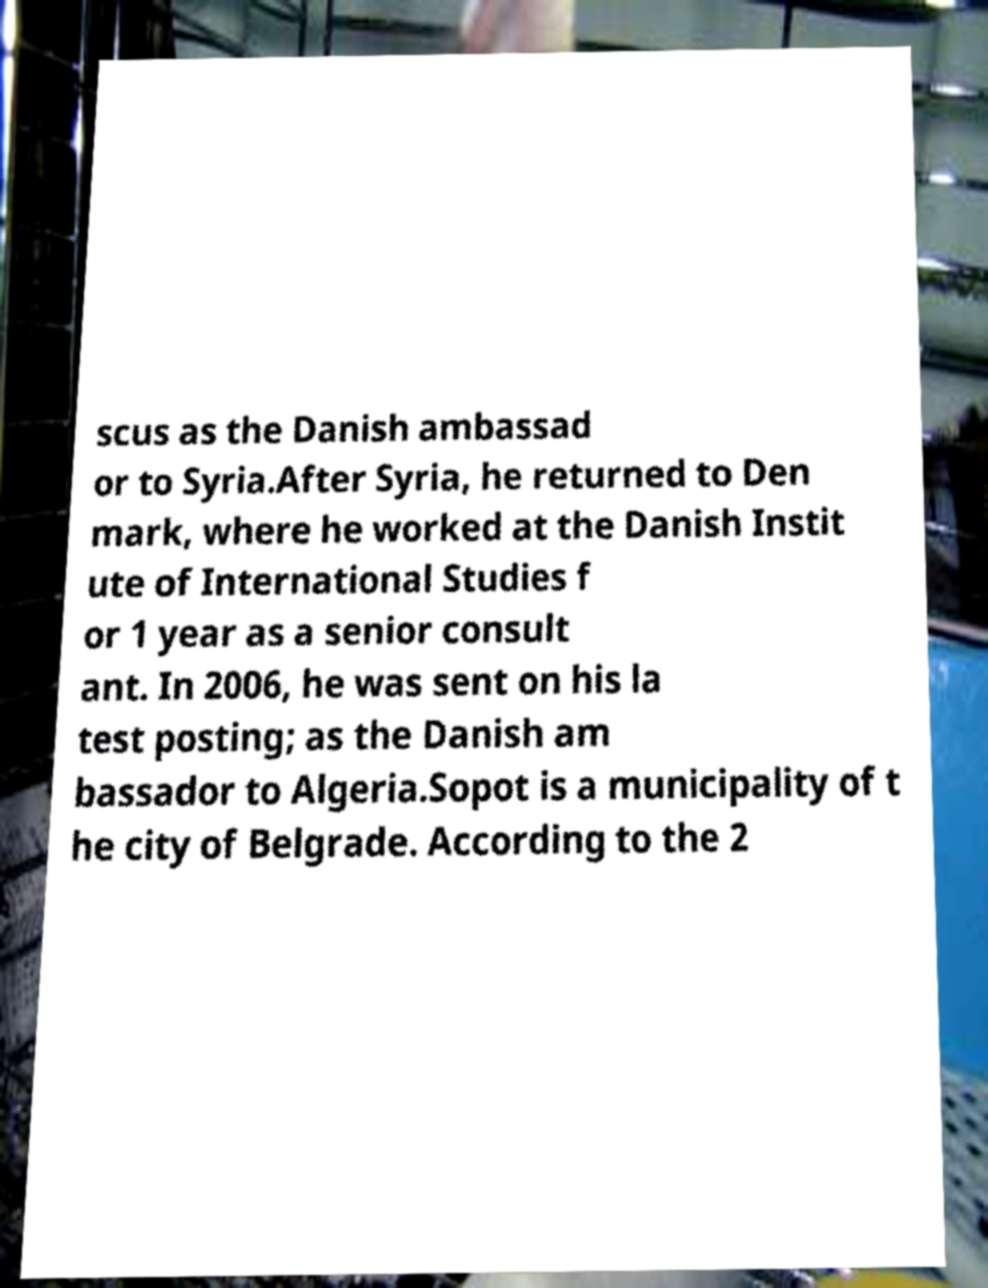I need the written content from this picture converted into text. Can you do that? scus as the Danish ambassad or to Syria.After Syria, he returned to Den mark, where he worked at the Danish Instit ute of International Studies f or 1 year as a senior consult ant. In 2006, he was sent on his la test posting; as the Danish am bassador to Algeria.Sopot is a municipality of t he city of Belgrade. According to the 2 